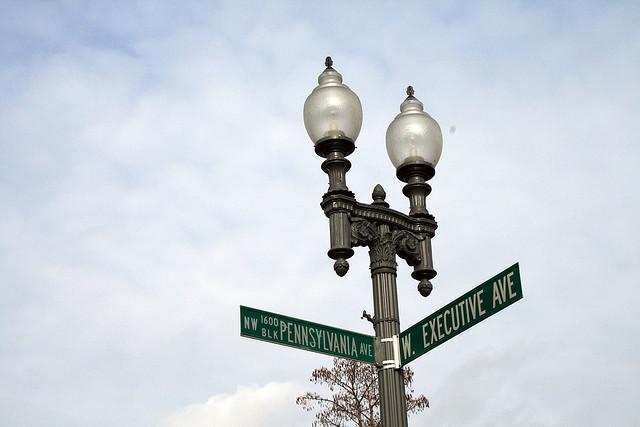How many light bulbs are there?
Give a very brief answer. 2. 